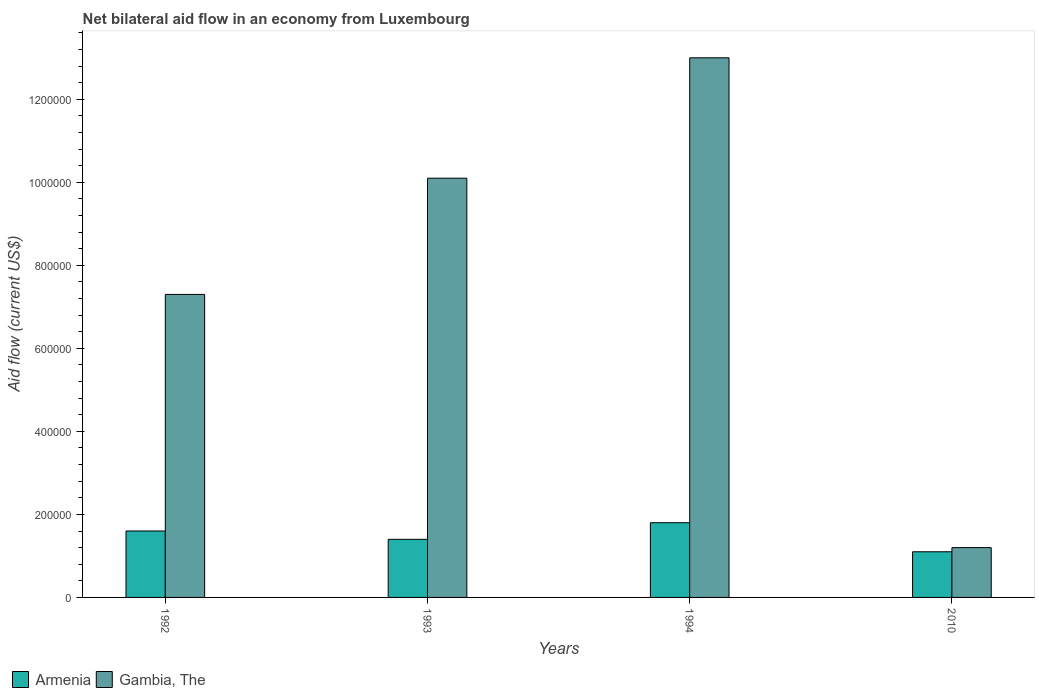How many different coloured bars are there?
Your response must be concise. 2. How many groups of bars are there?
Your answer should be compact. 4. Are the number of bars per tick equal to the number of legend labels?
Keep it short and to the point. Yes. How many bars are there on the 2nd tick from the left?
Give a very brief answer. 2. What is the net bilateral aid flow in Gambia, The in 1994?
Offer a terse response. 1.30e+06. Across all years, what is the maximum net bilateral aid flow in Armenia?
Provide a succinct answer. 1.80e+05. What is the total net bilateral aid flow in Armenia in the graph?
Your answer should be very brief. 5.90e+05. What is the difference between the net bilateral aid flow in Gambia, The in 1992 and that in 2010?
Make the answer very short. 6.10e+05. What is the difference between the net bilateral aid flow in Gambia, The in 1993 and the net bilateral aid flow in Armenia in 1994?
Your answer should be compact. 8.30e+05. What is the average net bilateral aid flow in Armenia per year?
Make the answer very short. 1.48e+05. In the year 1992, what is the difference between the net bilateral aid flow in Armenia and net bilateral aid flow in Gambia, The?
Provide a short and direct response. -5.70e+05. In how many years, is the net bilateral aid flow in Gambia, The greater than 680000 US$?
Offer a terse response. 3. What is the ratio of the net bilateral aid flow in Armenia in 1993 to that in 2010?
Give a very brief answer. 1.27. In how many years, is the net bilateral aid flow in Armenia greater than the average net bilateral aid flow in Armenia taken over all years?
Offer a very short reply. 2. Is the sum of the net bilateral aid flow in Gambia, The in 1992 and 1994 greater than the maximum net bilateral aid flow in Armenia across all years?
Keep it short and to the point. Yes. What does the 1st bar from the left in 1994 represents?
Make the answer very short. Armenia. What does the 2nd bar from the right in 1992 represents?
Keep it short and to the point. Armenia. How many bars are there?
Offer a terse response. 8. Are all the bars in the graph horizontal?
Your response must be concise. No. Are the values on the major ticks of Y-axis written in scientific E-notation?
Offer a very short reply. No. How many legend labels are there?
Ensure brevity in your answer.  2. How are the legend labels stacked?
Your response must be concise. Horizontal. What is the title of the graph?
Your response must be concise. Net bilateral aid flow in an economy from Luxembourg. Does "Guam" appear as one of the legend labels in the graph?
Make the answer very short. No. What is the label or title of the X-axis?
Your answer should be compact. Years. What is the Aid flow (current US$) in Armenia in 1992?
Offer a terse response. 1.60e+05. What is the Aid flow (current US$) in Gambia, The in 1992?
Give a very brief answer. 7.30e+05. What is the Aid flow (current US$) in Armenia in 1993?
Keep it short and to the point. 1.40e+05. What is the Aid flow (current US$) in Gambia, The in 1993?
Offer a terse response. 1.01e+06. What is the Aid flow (current US$) of Armenia in 1994?
Provide a succinct answer. 1.80e+05. What is the Aid flow (current US$) of Gambia, The in 1994?
Keep it short and to the point. 1.30e+06. What is the Aid flow (current US$) of Armenia in 2010?
Keep it short and to the point. 1.10e+05. What is the Aid flow (current US$) of Gambia, The in 2010?
Provide a short and direct response. 1.20e+05. Across all years, what is the maximum Aid flow (current US$) in Armenia?
Ensure brevity in your answer.  1.80e+05. Across all years, what is the maximum Aid flow (current US$) of Gambia, The?
Provide a succinct answer. 1.30e+06. Across all years, what is the minimum Aid flow (current US$) in Gambia, The?
Offer a very short reply. 1.20e+05. What is the total Aid flow (current US$) of Armenia in the graph?
Keep it short and to the point. 5.90e+05. What is the total Aid flow (current US$) in Gambia, The in the graph?
Offer a terse response. 3.16e+06. What is the difference between the Aid flow (current US$) in Gambia, The in 1992 and that in 1993?
Ensure brevity in your answer.  -2.80e+05. What is the difference between the Aid flow (current US$) in Gambia, The in 1992 and that in 1994?
Your answer should be compact. -5.70e+05. What is the difference between the Aid flow (current US$) in Gambia, The in 1993 and that in 1994?
Your response must be concise. -2.90e+05. What is the difference between the Aid flow (current US$) of Armenia in 1993 and that in 2010?
Offer a very short reply. 3.00e+04. What is the difference between the Aid flow (current US$) in Gambia, The in 1993 and that in 2010?
Give a very brief answer. 8.90e+05. What is the difference between the Aid flow (current US$) in Armenia in 1994 and that in 2010?
Provide a short and direct response. 7.00e+04. What is the difference between the Aid flow (current US$) in Gambia, The in 1994 and that in 2010?
Your response must be concise. 1.18e+06. What is the difference between the Aid flow (current US$) of Armenia in 1992 and the Aid flow (current US$) of Gambia, The in 1993?
Your answer should be very brief. -8.50e+05. What is the difference between the Aid flow (current US$) of Armenia in 1992 and the Aid flow (current US$) of Gambia, The in 1994?
Provide a short and direct response. -1.14e+06. What is the difference between the Aid flow (current US$) of Armenia in 1993 and the Aid flow (current US$) of Gambia, The in 1994?
Offer a very short reply. -1.16e+06. What is the average Aid flow (current US$) of Armenia per year?
Offer a terse response. 1.48e+05. What is the average Aid flow (current US$) of Gambia, The per year?
Your response must be concise. 7.90e+05. In the year 1992, what is the difference between the Aid flow (current US$) in Armenia and Aid flow (current US$) in Gambia, The?
Provide a succinct answer. -5.70e+05. In the year 1993, what is the difference between the Aid flow (current US$) in Armenia and Aid flow (current US$) in Gambia, The?
Offer a very short reply. -8.70e+05. In the year 1994, what is the difference between the Aid flow (current US$) of Armenia and Aid flow (current US$) of Gambia, The?
Keep it short and to the point. -1.12e+06. What is the ratio of the Aid flow (current US$) of Gambia, The in 1992 to that in 1993?
Give a very brief answer. 0.72. What is the ratio of the Aid flow (current US$) of Gambia, The in 1992 to that in 1994?
Ensure brevity in your answer.  0.56. What is the ratio of the Aid flow (current US$) in Armenia in 1992 to that in 2010?
Your answer should be very brief. 1.45. What is the ratio of the Aid flow (current US$) in Gambia, The in 1992 to that in 2010?
Give a very brief answer. 6.08. What is the ratio of the Aid flow (current US$) of Gambia, The in 1993 to that in 1994?
Your answer should be very brief. 0.78. What is the ratio of the Aid flow (current US$) of Armenia in 1993 to that in 2010?
Your answer should be very brief. 1.27. What is the ratio of the Aid flow (current US$) of Gambia, The in 1993 to that in 2010?
Give a very brief answer. 8.42. What is the ratio of the Aid flow (current US$) in Armenia in 1994 to that in 2010?
Your answer should be compact. 1.64. What is the ratio of the Aid flow (current US$) in Gambia, The in 1994 to that in 2010?
Give a very brief answer. 10.83. What is the difference between the highest and the second highest Aid flow (current US$) in Gambia, The?
Offer a terse response. 2.90e+05. What is the difference between the highest and the lowest Aid flow (current US$) of Gambia, The?
Your answer should be very brief. 1.18e+06. 